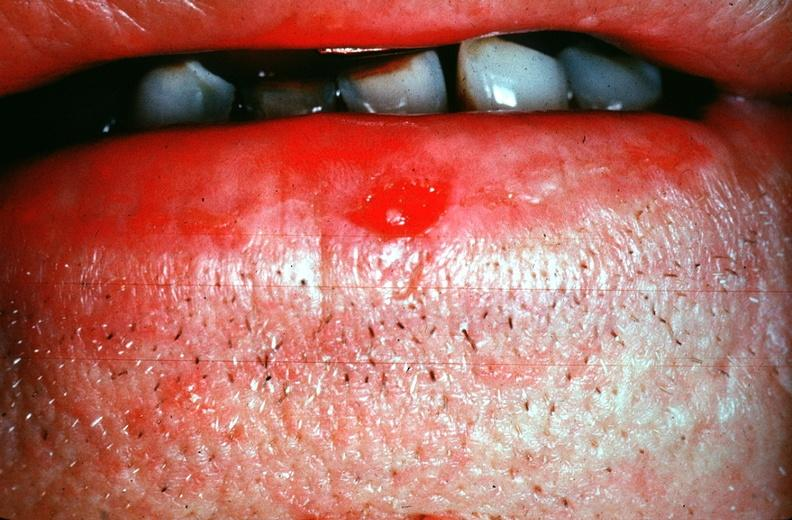does spinal fluid show squamous cell carcinoma, lip?
Answer the question using a single word or phrase. No 